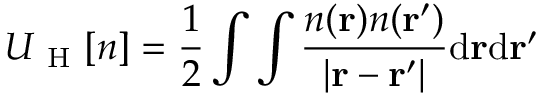<formula> <loc_0><loc_0><loc_500><loc_500>U _ { H } [ n ] = \frac { 1 } { 2 } \int \int \frac { n ( r ) n ( r ^ { \prime } ) } { | r - r ^ { \prime } | } d r d r ^ { \prime }</formula> 